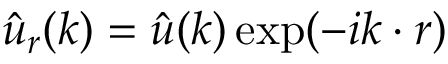<formula> <loc_0><loc_0><loc_500><loc_500>\hat { \boldsymbol u } _ { r } ( \boldsymbol k ) = \hat { \boldsymbol u } ( \boldsymbol k ) \exp ( - i \boldsymbol k \cdot \boldsymbol r )</formula> 